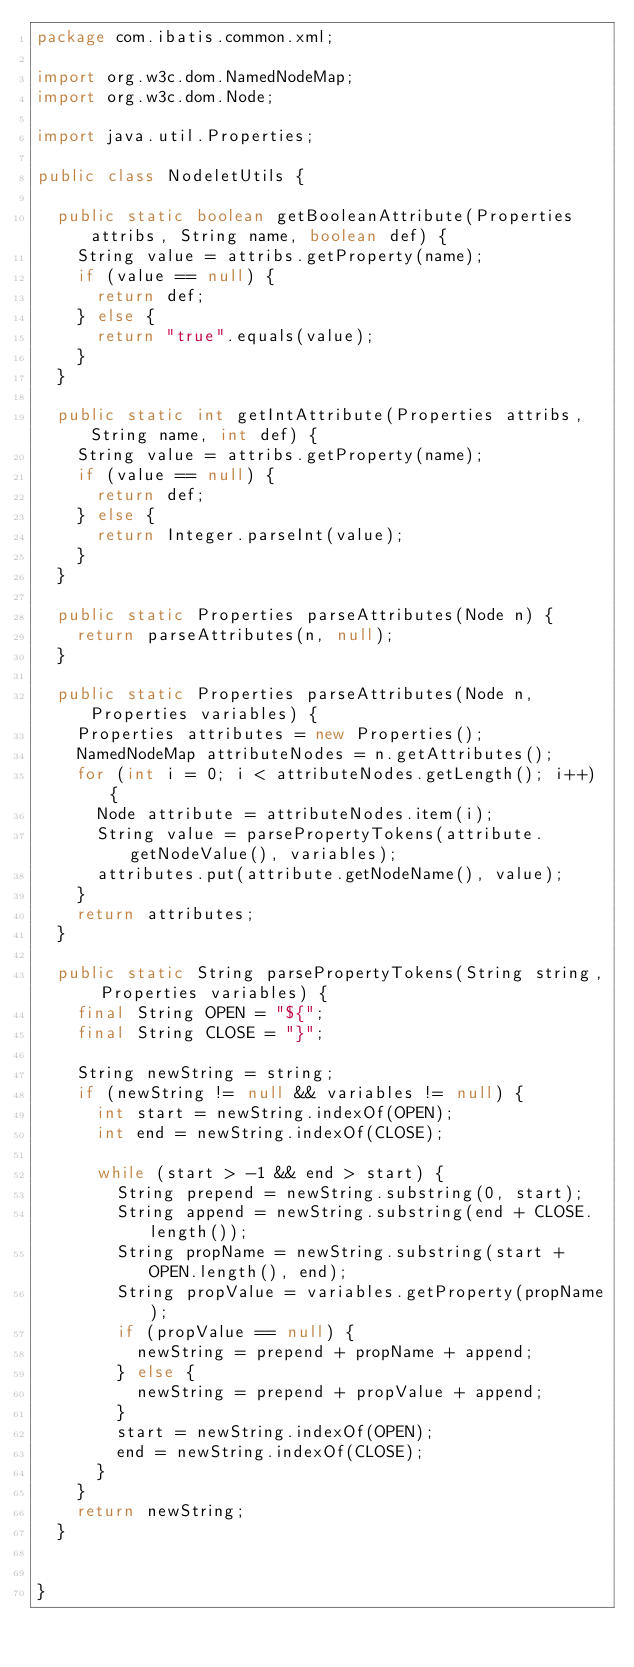Convert code to text. <code><loc_0><loc_0><loc_500><loc_500><_Java_>package com.ibatis.common.xml;

import org.w3c.dom.NamedNodeMap;
import org.w3c.dom.Node;

import java.util.Properties;

public class NodeletUtils {

  public static boolean getBooleanAttribute(Properties attribs, String name, boolean def) {
    String value = attribs.getProperty(name);
    if (value == null) {
      return def;
    } else {
      return "true".equals(value);
    }
  }

  public static int getIntAttribute(Properties attribs, String name, int def) {
    String value = attribs.getProperty(name);
    if (value == null) {
      return def;
    } else {
      return Integer.parseInt(value);
    }
  }

  public static Properties parseAttributes(Node n) {
    return parseAttributes(n, null);
  }

  public static Properties parseAttributes(Node n, Properties variables) {
    Properties attributes = new Properties();
    NamedNodeMap attributeNodes = n.getAttributes();
    for (int i = 0; i < attributeNodes.getLength(); i++) {
      Node attribute = attributeNodes.item(i);
      String value = parsePropertyTokens(attribute.getNodeValue(), variables);
      attributes.put(attribute.getNodeName(), value);
    }
    return attributes;
  }

  public static String parsePropertyTokens(String string, Properties variables) {
    final String OPEN = "${";
    final String CLOSE = "}";

    String newString = string;
    if (newString != null && variables != null) {
      int start = newString.indexOf(OPEN);
      int end = newString.indexOf(CLOSE);

      while (start > -1 && end > start) {
        String prepend = newString.substring(0, start);
        String append = newString.substring(end + CLOSE.length());
        String propName = newString.substring(start + OPEN.length(), end);
        String propValue = variables.getProperty(propName);
        if (propValue == null) {
          newString = prepend + propName + append;
        } else {
          newString = prepend + propValue + append;
        }
        start = newString.indexOf(OPEN);
        end = newString.indexOf(CLOSE);
      }
    }
    return newString;
  }


}
</code> 